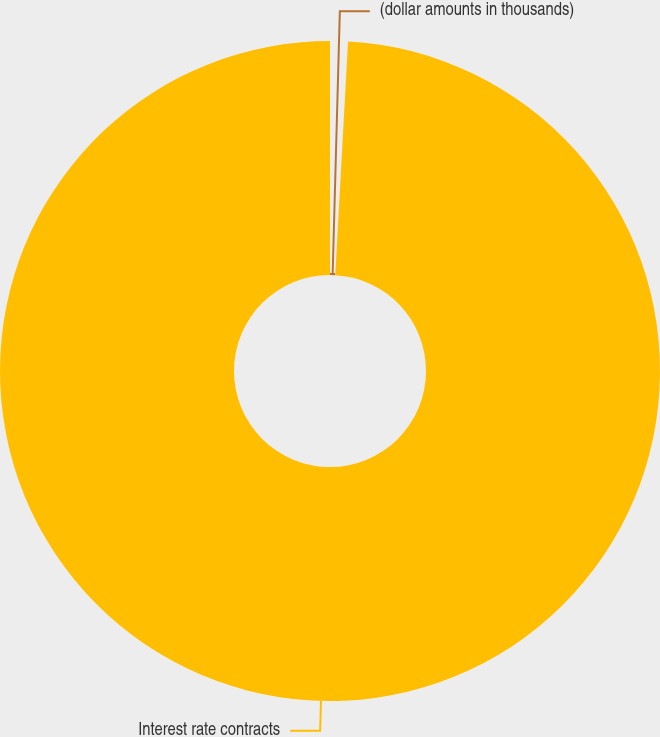<chart> <loc_0><loc_0><loc_500><loc_500><pie_chart><fcel>(dollar amounts in thousands)<fcel>Interest rate contracts<nl><fcel>0.87%<fcel>99.13%<nl></chart> 